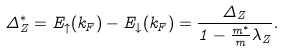Convert formula to latex. <formula><loc_0><loc_0><loc_500><loc_500>\Delta _ { Z } ^ { \ast } = E _ { \uparrow } ( k _ { F } ) - E _ { \downarrow } ( k _ { F } ) = \frac { \Delta _ { Z } } { 1 - \frac { m ^ { \ast } } { m } \lambda _ { Z } } .</formula> 